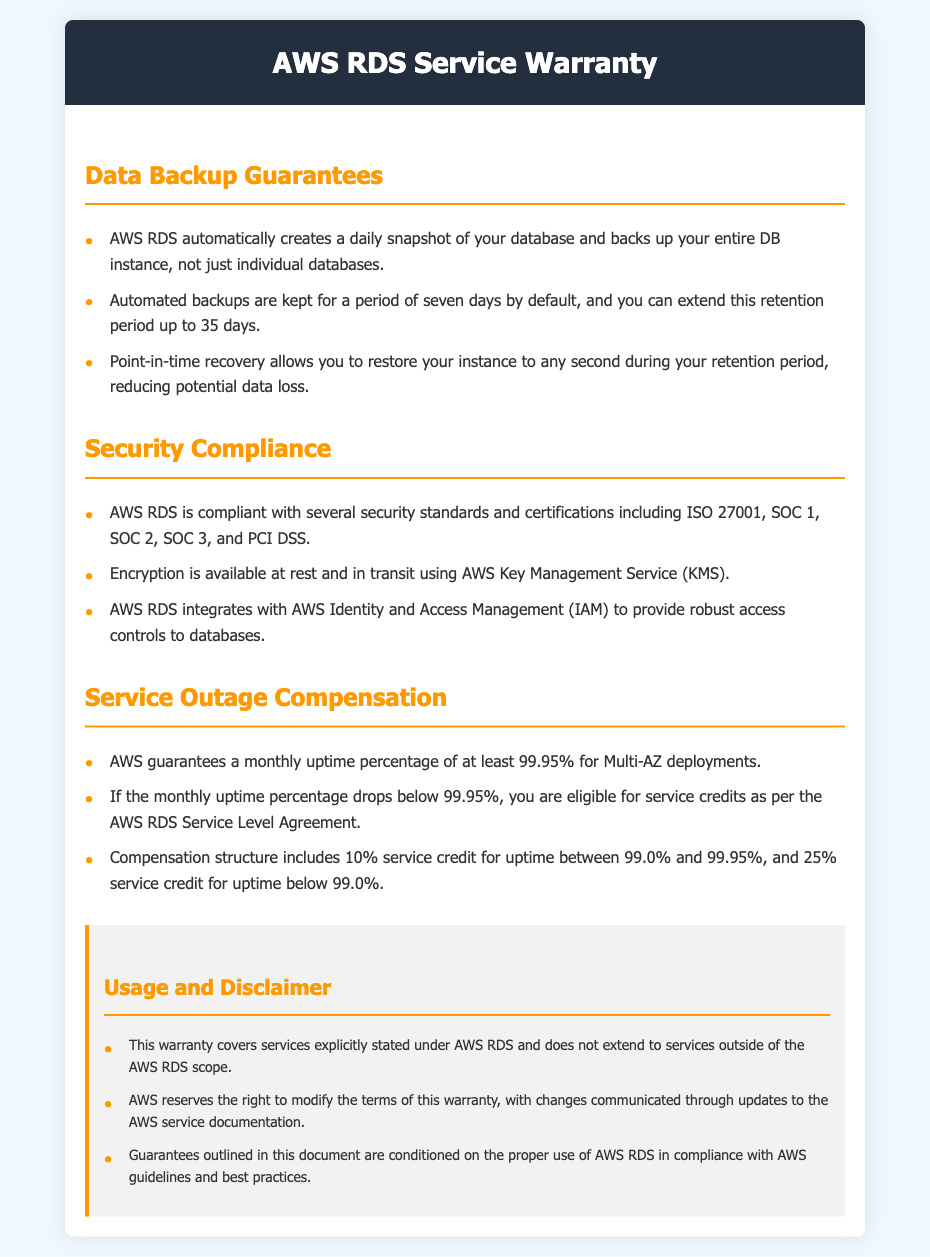What is the default retention period for automated backups? The document states that automated backups are kept for a period of seven days by default.
Answer: seven days How many days can the retention period for automated backups be extended to? The document mentions that you can extend this retention period up to 35 days.
Answer: 35 days What is the minimum guaranteed monthly uptime percentage for Multi-AZ deployments? According to the document, AWS guarantees a monthly uptime percentage of at least 99.95% for Multi-AZ deployments.
Answer: 99.95% What percentage of service credit is provided for uptime between 99.0% and 99.95%? The compensation structure includes 10% service credit for uptime between 99.0% and 99.95%.
Answer: 10% Which security standard is AWS RDS compliant with? The document lists compliance with several standards, including ISO 27001, which is explicitly mentioned.
Answer: ISO 27001 What recovery capability does AWS RDS provide during the retention period? The document states that point-in-time recovery allows you to restore your instance to any second during your retention period.
Answer: point-in-time recovery What service integrates with AWS RDS to provide robust access controls? The document mentions that AWS RDS integrates with AWS Identity and Access Management (IAM) for access controls.
Answer: AWS Identity and Access Management (IAM) What should you do to be eligible for service credits if uptime drops below the guaranteed percentage? The document specifies that you are eligible for service credits as per the AWS RDS Service Level Agreement.
Answer: AWS RDS Service Level Agreement 